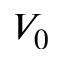Convert formula to latex. <formula><loc_0><loc_0><loc_500><loc_500>V _ { 0 }</formula> 